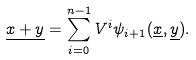<formula> <loc_0><loc_0><loc_500><loc_500>\underline { x + y } = \sum _ { i = 0 } ^ { n - 1 } V ^ { i } \psi _ { i + 1 } ( \underline { x } , \underline { y } ) .</formula> 